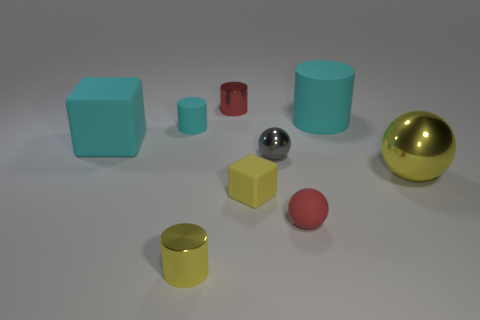Is there anything else that has the same shape as the red rubber object?
Ensure brevity in your answer.  Yes. Are there an equal number of small yellow matte blocks to the right of the matte sphere and small red matte balls?
Offer a very short reply. No. How many things are made of the same material as the red cylinder?
Ensure brevity in your answer.  3. There is another ball that is the same material as the big yellow ball; what color is it?
Give a very brief answer. Gray. Does the big metal thing have the same shape as the red matte object?
Provide a succinct answer. Yes. There is a tiny metal thing right of the metallic object behind the large cylinder; are there any cyan things that are left of it?
Offer a very short reply. Yes. How many small cubes have the same color as the large ball?
Offer a terse response. 1. What shape is the cyan rubber object that is the same size as the red shiny cylinder?
Give a very brief answer. Cylinder. Are there any large cyan matte objects left of the yellow cylinder?
Offer a very short reply. Yes. Is the yellow rubber block the same size as the gray metallic ball?
Ensure brevity in your answer.  Yes. 